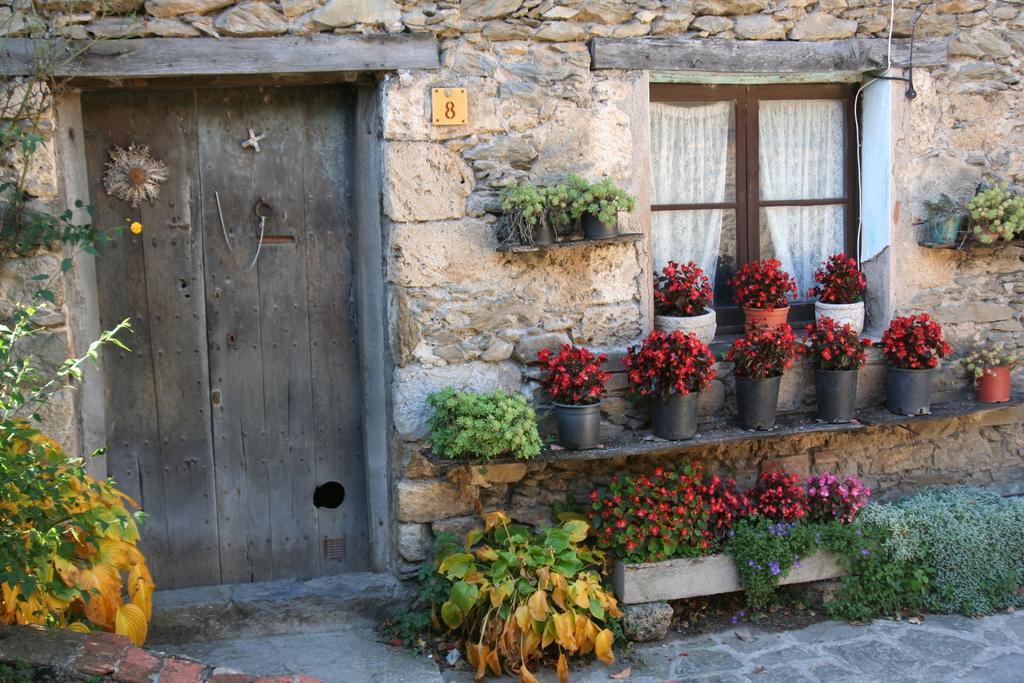Can you describe this image briefly? In this image there is a wooden door, beside the wooden door there is a wall, beside the wall there is a window, in front of the window there are a few plants. 